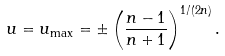Convert formula to latex. <formula><loc_0><loc_0><loc_500><loc_500>u = u _ { \max } = \pm \left ( \frac { n - 1 } { n + 1 } \right ) ^ { 1 / ( 2 n ) } .</formula> 